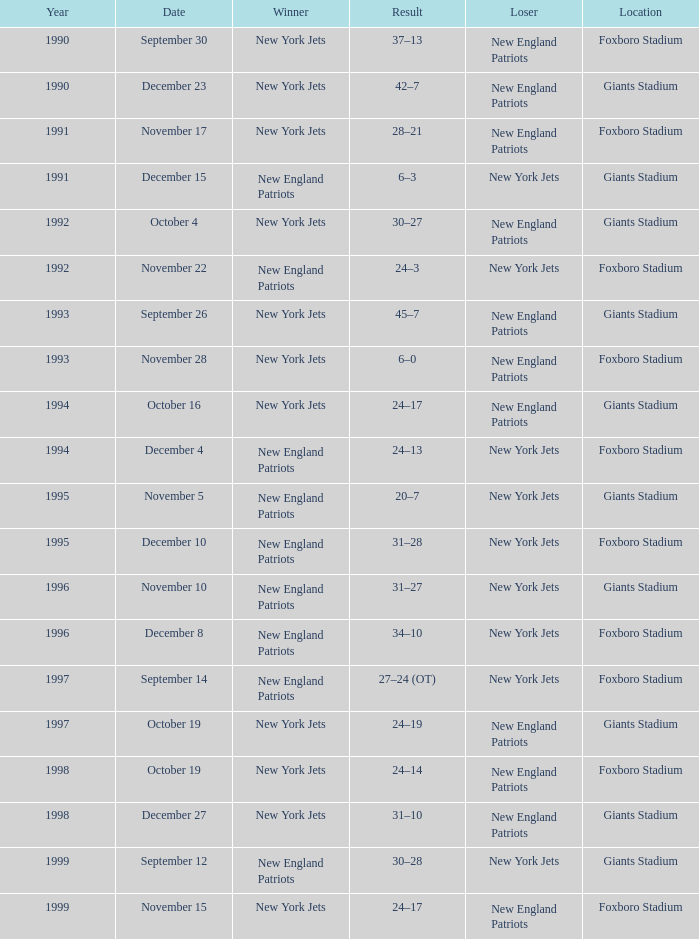In which year did the new york jets emerge as the winner with a 24-17 score, playing at giants stadium? 1994.0. 